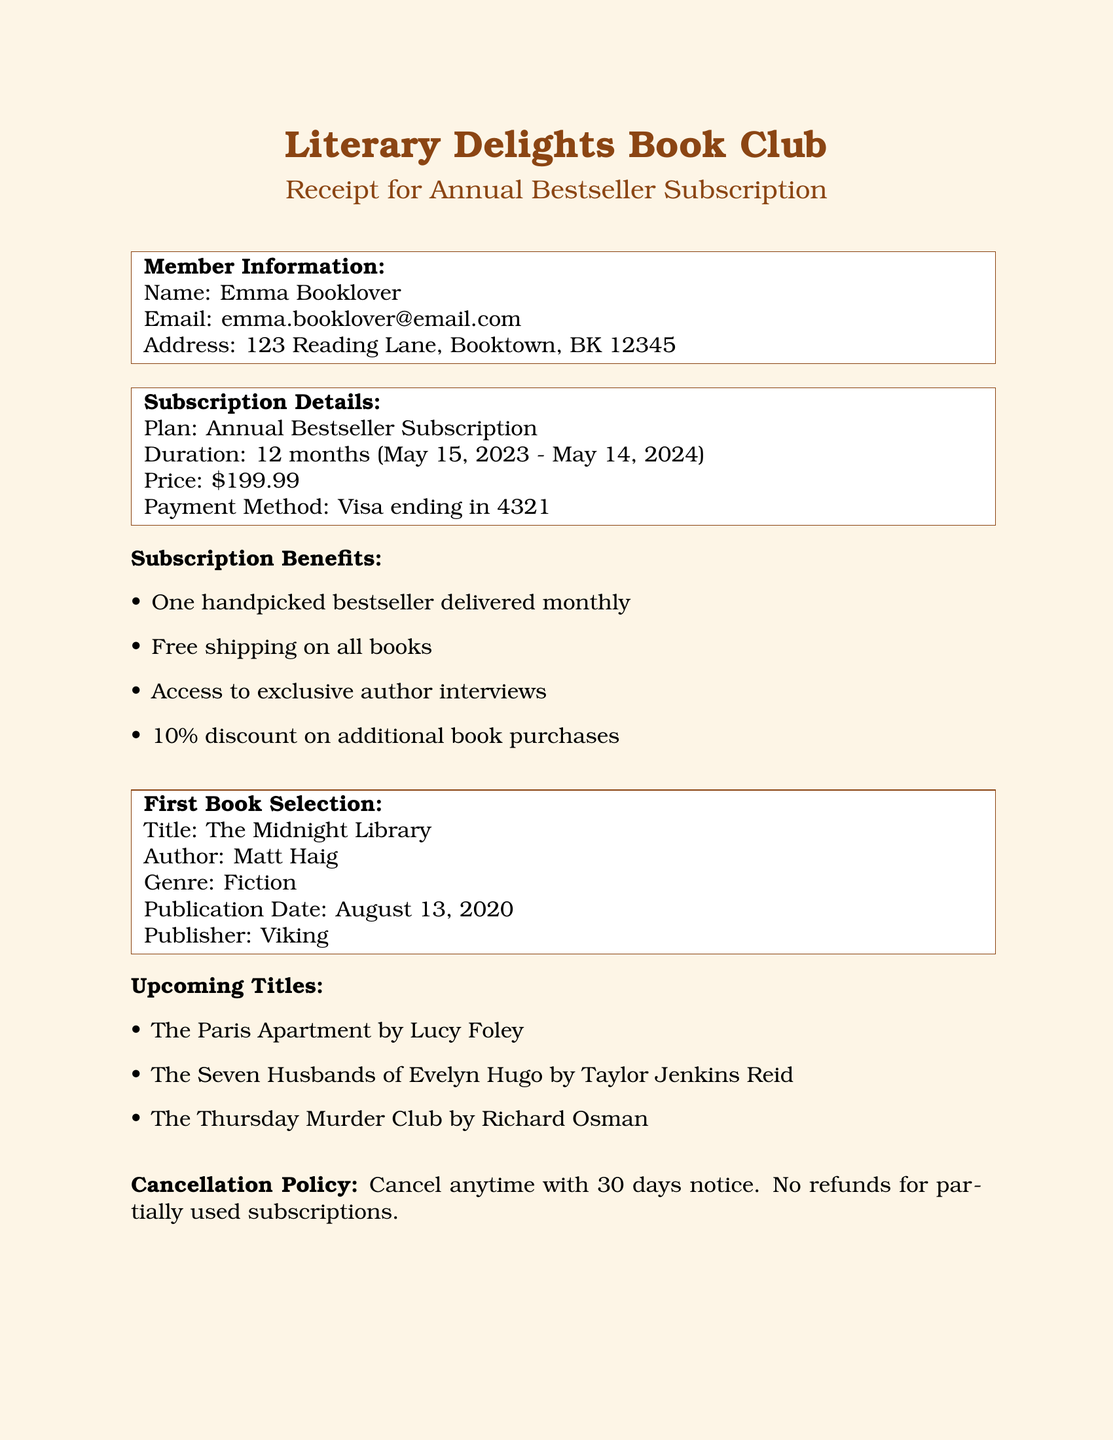what is the name of the book club? The name of the book club is mentioned at the top of the document.
Answer: Literary Delights Book Club what is the total cost of the subscription? The total cost of the subscription is specified in the subscription details section.
Answer: $199.99 who is the author of the first book selection? The author's name is provided with the first book selection details.
Answer: Matt Haig when does the subscription end? The end date of the subscription is listed in the subscription details.
Answer: May 14, 2024 what is the duration of the subscription plan? The duration is clearly stated in the subscription details section.
Answer: 12 months what is the first book selection's genre? The genre of the first book is included in its selection details.
Answer: Fiction what is the cancellation policy? The cancellation policy is directly stated in the document.
Answer: Cancel anytime with 30 days notice. No refunds for partially used subscriptions how many upcoming titles are listed? The number of upcoming titles can be counted from the upcoming titles section.
Answer: 3 what payment method was used for the subscription? The payment method is found in the subscription details section.
Answer: Visa ending in 4321 